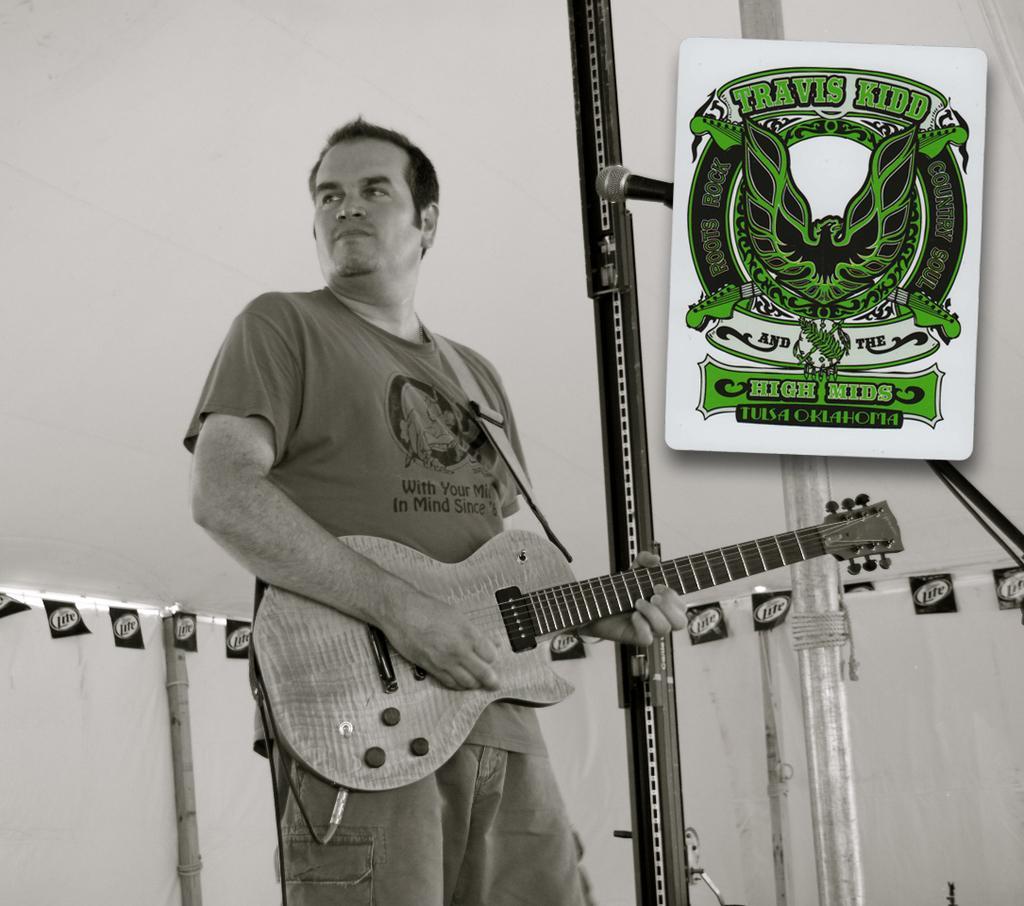In one or two sentences, can you explain what this image depicts? In this image a man wearing a gray color tea shirt and holding a guitar on his hand and back side of him there is a hoarding board and there is some text written on board Travis kid and there is a mike backside of the board. and there is a wall back side of man. 